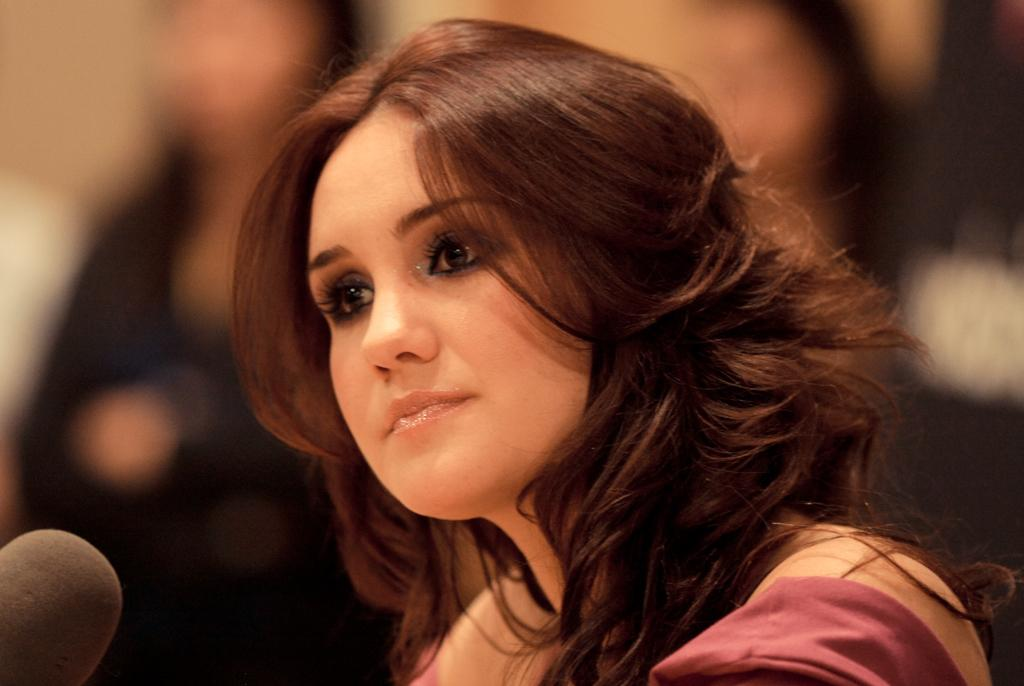Who is the main subject in the foreground of the image? There is a woman in the foreground of the image. What type of land is visible in the background of the image? There is no land visible in the image, as it only features a woman in the foreground. 